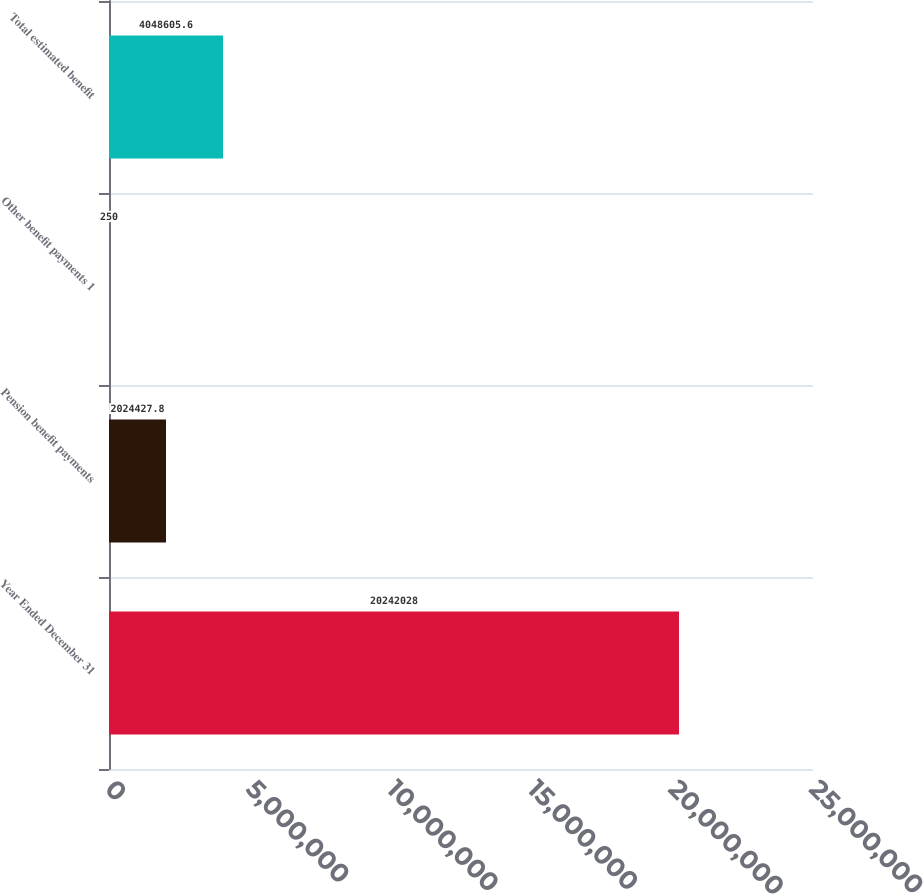<chart> <loc_0><loc_0><loc_500><loc_500><bar_chart><fcel>Year Ended December 31<fcel>Pension benefit payments<fcel>Other benefit payments 1<fcel>Total estimated benefit<nl><fcel>2.0242e+07<fcel>2.02443e+06<fcel>250<fcel>4.04861e+06<nl></chart> 